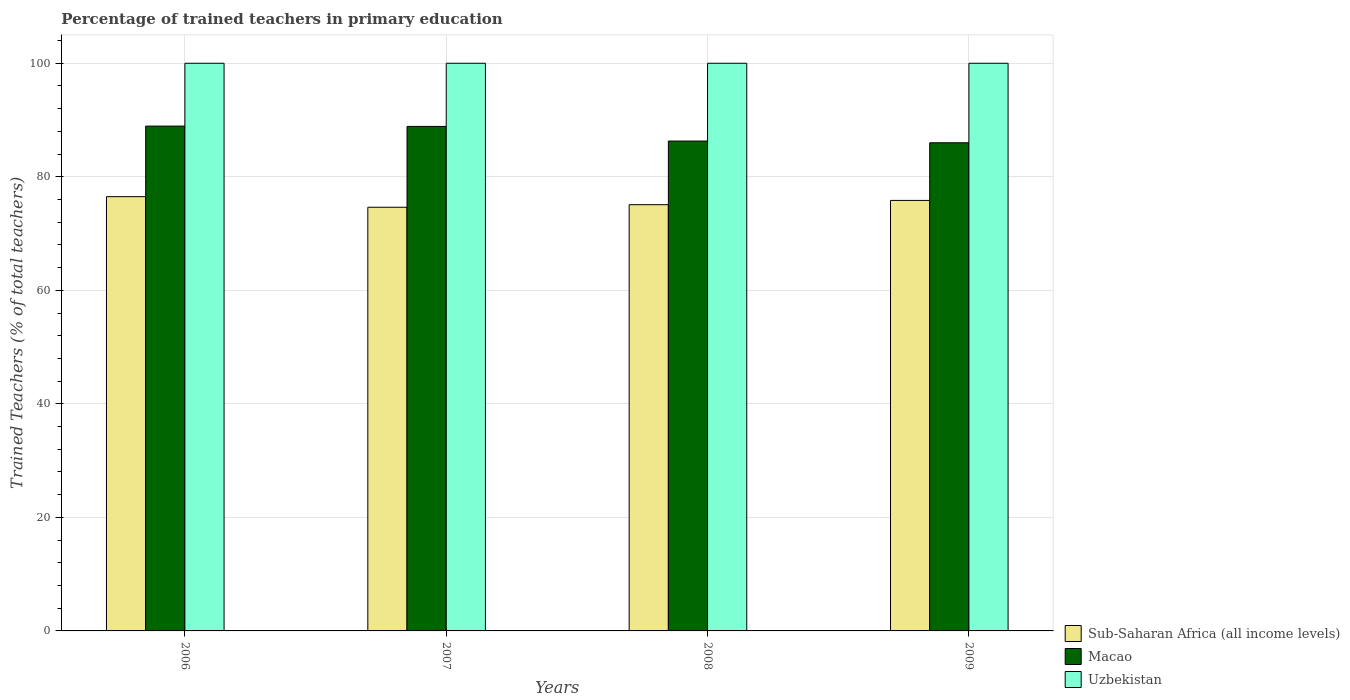How many groups of bars are there?
Your response must be concise. 4. Are the number of bars on each tick of the X-axis equal?
Keep it short and to the point. Yes. What is the label of the 4th group of bars from the left?
Ensure brevity in your answer.  2009. What is the percentage of trained teachers in Uzbekistan in 2006?
Your response must be concise. 100. Across all years, what is the maximum percentage of trained teachers in Macao?
Ensure brevity in your answer.  88.93. Across all years, what is the minimum percentage of trained teachers in Macao?
Provide a succinct answer. 85.99. In which year was the percentage of trained teachers in Macao minimum?
Offer a terse response. 2009. What is the total percentage of trained teachers in Uzbekistan in the graph?
Your response must be concise. 400. What is the difference between the percentage of trained teachers in Sub-Saharan Africa (all income levels) in 2007 and that in 2008?
Your answer should be compact. -0.45. What is the difference between the percentage of trained teachers in Uzbekistan in 2008 and the percentage of trained teachers in Sub-Saharan Africa (all income levels) in 2009?
Make the answer very short. 24.16. What is the average percentage of trained teachers in Sub-Saharan Africa (all income levels) per year?
Make the answer very short. 75.51. In the year 2008, what is the difference between the percentage of trained teachers in Macao and percentage of trained teachers in Uzbekistan?
Offer a terse response. -13.7. What is the difference between the highest and the second highest percentage of trained teachers in Sub-Saharan Africa (all income levels)?
Keep it short and to the point. 0.66. What is the difference between the highest and the lowest percentage of trained teachers in Macao?
Provide a short and direct response. 2.94. What does the 1st bar from the left in 2008 represents?
Make the answer very short. Sub-Saharan Africa (all income levels). What does the 2nd bar from the right in 2006 represents?
Offer a very short reply. Macao. Are all the bars in the graph horizontal?
Provide a succinct answer. No. How many years are there in the graph?
Your response must be concise. 4. Are the values on the major ticks of Y-axis written in scientific E-notation?
Your answer should be very brief. No. Does the graph contain any zero values?
Your answer should be compact. No. Does the graph contain grids?
Provide a short and direct response. Yes. Where does the legend appear in the graph?
Offer a very short reply. Bottom right. How many legend labels are there?
Your response must be concise. 3. How are the legend labels stacked?
Offer a very short reply. Vertical. What is the title of the graph?
Ensure brevity in your answer.  Percentage of trained teachers in primary education. What is the label or title of the Y-axis?
Your answer should be compact. Trained Teachers (% of total teachers). What is the Trained Teachers (% of total teachers) of Sub-Saharan Africa (all income levels) in 2006?
Offer a very short reply. 76.5. What is the Trained Teachers (% of total teachers) in Macao in 2006?
Ensure brevity in your answer.  88.93. What is the Trained Teachers (% of total teachers) of Sub-Saharan Africa (all income levels) in 2007?
Give a very brief answer. 74.64. What is the Trained Teachers (% of total teachers) in Macao in 2007?
Make the answer very short. 88.88. What is the Trained Teachers (% of total teachers) of Sub-Saharan Africa (all income levels) in 2008?
Ensure brevity in your answer.  75.08. What is the Trained Teachers (% of total teachers) of Macao in 2008?
Keep it short and to the point. 86.3. What is the Trained Teachers (% of total teachers) in Sub-Saharan Africa (all income levels) in 2009?
Your response must be concise. 75.84. What is the Trained Teachers (% of total teachers) of Macao in 2009?
Your response must be concise. 85.99. Across all years, what is the maximum Trained Teachers (% of total teachers) of Sub-Saharan Africa (all income levels)?
Provide a succinct answer. 76.5. Across all years, what is the maximum Trained Teachers (% of total teachers) in Macao?
Give a very brief answer. 88.93. Across all years, what is the minimum Trained Teachers (% of total teachers) of Sub-Saharan Africa (all income levels)?
Offer a terse response. 74.64. Across all years, what is the minimum Trained Teachers (% of total teachers) in Macao?
Your answer should be very brief. 85.99. Across all years, what is the minimum Trained Teachers (% of total teachers) in Uzbekistan?
Your answer should be very brief. 100. What is the total Trained Teachers (% of total teachers) in Sub-Saharan Africa (all income levels) in the graph?
Give a very brief answer. 302.06. What is the total Trained Teachers (% of total teachers) in Macao in the graph?
Your response must be concise. 350.09. What is the difference between the Trained Teachers (% of total teachers) in Sub-Saharan Africa (all income levels) in 2006 and that in 2007?
Your answer should be very brief. 1.86. What is the difference between the Trained Teachers (% of total teachers) in Macao in 2006 and that in 2007?
Provide a succinct answer. 0.06. What is the difference between the Trained Teachers (% of total teachers) of Sub-Saharan Africa (all income levels) in 2006 and that in 2008?
Your answer should be compact. 1.41. What is the difference between the Trained Teachers (% of total teachers) in Macao in 2006 and that in 2008?
Make the answer very short. 2.63. What is the difference between the Trained Teachers (% of total teachers) in Uzbekistan in 2006 and that in 2008?
Keep it short and to the point. 0. What is the difference between the Trained Teachers (% of total teachers) of Sub-Saharan Africa (all income levels) in 2006 and that in 2009?
Your response must be concise. 0.66. What is the difference between the Trained Teachers (% of total teachers) in Macao in 2006 and that in 2009?
Your response must be concise. 2.94. What is the difference between the Trained Teachers (% of total teachers) in Sub-Saharan Africa (all income levels) in 2007 and that in 2008?
Offer a terse response. -0.45. What is the difference between the Trained Teachers (% of total teachers) of Macao in 2007 and that in 2008?
Your answer should be very brief. 2.58. What is the difference between the Trained Teachers (% of total teachers) of Sub-Saharan Africa (all income levels) in 2007 and that in 2009?
Your answer should be very brief. -1.2. What is the difference between the Trained Teachers (% of total teachers) in Macao in 2007 and that in 2009?
Offer a terse response. 2.88. What is the difference between the Trained Teachers (% of total teachers) in Sub-Saharan Africa (all income levels) in 2008 and that in 2009?
Provide a short and direct response. -0.75. What is the difference between the Trained Teachers (% of total teachers) in Macao in 2008 and that in 2009?
Provide a succinct answer. 0.3. What is the difference between the Trained Teachers (% of total teachers) in Sub-Saharan Africa (all income levels) in 2006 and the Trained Teachers (% of total teachers) in Macao in 2007?
Keep it short and to the point. -12.38. What is the difference between the Trained Teachers (% of total teachers) in Sub-Saharan Africa (all income levels) in 2006 and the Trained Teachers (% of total teachers) in Uzbekistan in 2007?
Provide a short and direct response. -23.5. What is the difference between the Trained Teachers (% of total teachers) in Macao in 2006 and the Trained Teachers (% of total teachers) in Uzbekistan in 2007?
Offer a terse response. -11.07. What is the difference between the Trained Teachers (% of total teachers) in Sub-Saharan Africa (all income levels) in 2006 and the Trained Teachers (% of total teachers) in Macao in 2008?
Make the answer very short. -9.8. What is the difference between the Trained Teachers (% of total teachers) of Sub-Saharan Africa (all income levels) in 2006 and the Trained Teachers (% of total teachers) of Uzbekistan in 2008?
Your response must be concise. -23.5. What is the difference between the Trained Teachers (% of total teachers) in Macao in 2006 and the Trained Teachers (% of total teachers) in Uzbekistan in 2008?
Give a very brief answer. -11.07. What is the difference between the Trained Teachers (% of total teachers) in Sub-Saharan Africa (all income levels) in 2006 and the Trained Teachers (% of total teachers) in Macao in 2009?
Provide a short and direct response. -9.5. What is the difference between the Trained Teachers (% of total teachers) of Sub-Saharan Africa (all income levels) in 2006 and the Trained Teachers (% of total teachers) of Uzbekistan in 2009?
Ensure brevity in your answer.  -23.5. What is the difference between the Trained Teachers (% of total teachers) of Macao in 2006 and the Trained Teachers (% of total teachers) of Uzbekistan in 2009?
Give a very brief answer. -11.07. What is the difference between the Trained Teachers (% of total teachers) in Sub-Saharan Africa (all income levels) in 2007 and the Trained Teachers (% of total teachers) in Macao in 2008?
Your response must be concise. -11.66. What is the difference between the Trained Teachers (% of total teachers) of Sub-Saharan Africa (all income levels) in 2007 and the Trained Teachers (% of total teachers) of Uzbekistan in 2008?
Your answer should be very brief. -25.36. What is the difference between the Trained Teachers (% of total teachers) in Macao in 2007 and the Trained Teachers (% of total teachers) in Uzbekistan in 2008?
Your answer should be compact. -11.12. What is the difference between the Trained Teachers (% of total teachers) of Sub-Saharan Africa (all income levels) in 2007 and the Trained Teachers (% of total teachers) of Macao in 2009?
Keep it short and to the point. -11.36. What is the difference between the Trained Teachers (% of total teachers) of Sub-Saharan Africa (all income levels) in 2007 and the Trained Teachers (% of total teachers) of Uzbekistan in 2009?
Your answer should be very brief. -25.36. What is the difference between the Trained Teachers (% of total teachers) in Macao in 2007 and the Trained Teachers (% of total teachers) in Uzbekistan in 2009?
Your answer should be compact. -11.12. What is the difference between the Trained Teachers (% of total teachers) in Sub-Saharan Africa (all income levels) in 2008 and the Trained Teachers (% of total teachers) in Macao in 2009?
Your answer should be very brief. -10.91. What is the difference between the Trained Teachers (% of total teachers) of Sub-Saharan Africa (all income levels) in 2008 and the Trained Teachers (% of total teachers) of Uzbekistan in 2009?
Keep it short and to the point. -24.92. What is the difference between the Trained Teachers (% of total teachers) of Macao in 2008 and the Trained Teachers (% of total teachers) of Uzbekistan in 2009?
Make the answer very short. -13.7. What is the average Trained Teachers (% of total teachers) in Sub-Saharan Africa (all income levels) per year?
Ensure brevity in your answer.  75.51. What is the average Trained Teachers (% of total teachers) in Macao per year?
Keep it short and to the point. 87.52. In the year 2006, what is the difference between the Trained Teachers (% of total teachers) of Sub-Saharan Africa (all income levels) and Trained Teachers (% of total teachers) of Macao?
Your answer should be very brief. -12.43. In the year 2006, what is the difference between the Trained Teachers (% of total teachers) of Sub-Saharan Africa (all income levels) and Trained Teachers (% of total teachers) of Uzbekistan?
Provide a succinct answer. -23.5. In the year 2006, what is the difference between the Trained Teachers (% of total teachers) of Macao and Trained Teachers (% of total teachers) of Uzbekistan?
Provide a succinct answer. -11.07. In the year 2007, what is the difference between the Trained Teachers (% of total teachers) in Sub-Saharan Africa (all income levels) and Trained Teachers (% of total teachers) in Macao?
Your response must be concise. -14.24. In the year 2007, what is the difference between the Trained Teachers (% of total teachers) of Sub-Saharan Africa (all income levels) and Trained Teachers (% of total teachers) of Uzbekistan?
Keep it short and to the point. -25.36. In the year 2007, what is the difference between the Trained Teachers (% of total teachers) in Macao and Trained Teachers (% of total teachers) in Uzbekistan?
Ensure brevity in your answer.  -11.12. In the year 2008, what is the difference between the Trained Teachers (% of total teachers) of Sub-Saharan Africa (all income levels) and Trained Teachers (% of total teachers) of Macao?
Your answer should be compact. -11.21. In the year 2008, what is the difference between the Trained Teachers (% of total teachers) of Sub-Saharan Africa (all income levels) and Trained Teachers (% of total teachers) of Uzbekistan?
Ensure brevity in your answer.  -24.92. In the year 2008, what is the difference between the Trained Teachers (% of total teachers) of Macao and Trained Teachers (% of total teachers) of Uzbekistan?
Offer a very short reply. -13.7. In the year 2009, what is the difference between the Trained Teachers (% of total teachers) in Sub-Saharan Africa (all income levels) and Trained Teachers (% of total teachers) in Macao?
Offer a very short reply. -10.15. In the year 2009, what is the difference between the Trained Teachers (% of total teachers) in Sub-Saharan Africa (all income levels) and Trained Teachers (% of total teachers) in Uzbekistan?
Make the answer very short. -24.16. In the year 2009, what is the difference between the Trained Teachers (% of total teachers) in Macao and Trained Teachers (% of total teachers) in Uzbekistan?
Make the answer very short. -14.01. What is the ratio of the Trained Teachers (% of total teachers) of Sub-Saharan Africa (all income levels) in 2006 to that in 2007?
Offer a terse response. 1.02. What is the ratio of the Trained Teachers (% of total teachers) of Macao in 2006 to that in 2007?
Offer a terse response. 1. What is the ratio of the Trained Teachers (% of total teachers) in Sub-Saharan Africa (all income levels) in 2006 to that in 2008?
Offer a very short reply. 1.02. What is the ratio of the Trained Teachers (% of total teachers) of Macao in 2006 to that in 2008?
Offer a very short reply. 1.03. What is the ratio of the Trained Teachers (% of total teachers) in Sub-Saharan Africa (all income levels) in 2006 to that in 2009?
Ensure brevity in your answer.  1.01. What is the ratio of the Trained Teachers (% of total teachers) in Macao in 2006 to that in 2009?
Offer a terse response. 1.03. What is the ratio of the Trained Teachers (% of total teachers) in Macao in 2007 to that in 2008?
Offer a very short reply. 1.03. What is the ratio of the Trained Teachers (% of total teachers) of Uzbekistan in 2007 to that in 2008?
Offer a terse response. 1. What is the ratio of the Trained Teachers (% of total teachers) in Sub-Saharan Africa (all income levels) in 2007 to that in 2009?
Offer a terse response. 0.98. What is the ratio of the Trained Teachers (% of total teachers) in Macao in 2007 to that in 2009?
Provide a succinct answer. 1.03. What is the difference between the highest and the second highest Trained Teachers (% of total teachers) in Sub-Saharan Africa (all income levels)?
Offer a very short reply. 0.66. What is the difference between the highest and the second highest Trained Teachers (% of total teachers) of Macao?
Provide a short and direct response. 0.06. What is the difference between the highest and the lowest Trained Teachers (% of total teachers) in Sub-Saharan Africa (all income levels)?
Ensure brevity in your answer.  1.86. What is the difference between the highest and the lowest Trained Teachers (% of total teachers) of Macao?
Keep it short and to the point. 2.94. What is the difference between the highest and the lowest Trained Teachers (% of total teachers) of Uzbekistan?
Keep it short and to the point. 0. 